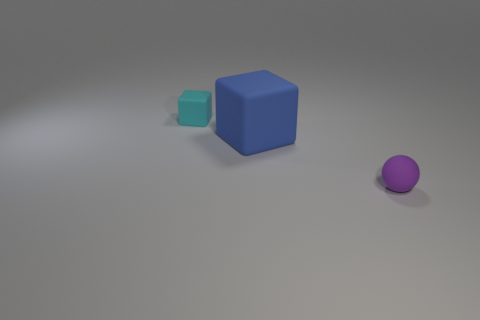Add 2 tiny red matte cylinders. How many objects exist? 5 Subtract all blue blocks. How many blocks are left? 1 Subtract all balls. How many objects are left? 2 Subtract 1 blocks. How many blocks are left? 1 Subtract all blue balls. Subtract all red cylinders. How many balls are left? 1 Subtract all tiny green rubber objects. Subtract all large things. How many objects are left? 2 Add 1 large blue rubber cubes. How many large blue rubber cubes are left? 2 Add 3 tiny blue cylinders. How many tiny blue cylinders exist? 3 Subtract 0 red cubes. How many objects are left? 3 